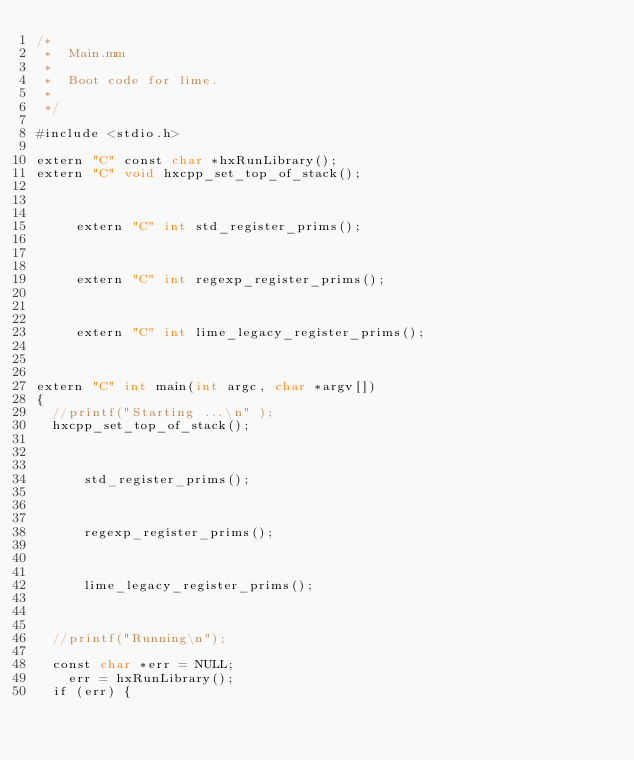Convert code to text. <code><loc_0><loc_0><loc_500><loc_500><_ObjectiveC_>/*
 *  Main.mm
 *
 *  Boot code for lime.
 *
 */

#include <stdio.h>

extern "C" const char *hxRunLibrary();
extern "C" void hxcpp_set_top_of_stack();
	

 
     extern "C" int std_register_prims();
 

 
     extern "C" int regexp_register_prims();
 

 
     extern "C" int lime_legacy_register_prims();
 

	
extern "C" int main(int argc, char *argv[])	
{
	//printf("Starting ...\n" );
	hxcpp_set_top_of_stack();

   	
     
      std_register_prims();
     
   	
     
      regexp_register_prims();
     
   	
     
      lime_legacy_register_prims();
     
   	
	
	//printf("Running\n");

	const char *err = NULL;
 		err = hxRunLibrary();
	if (err) {</code> 